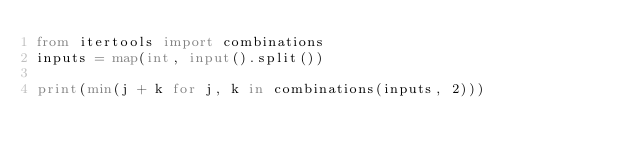<code> <loc_0><loc_0><loc_500><loc_500><_Python_>from itertools import combinations
inputs = map(int, input().split())

print(min(j + k for j, k in combinations(inputs, 2)))
</code> 